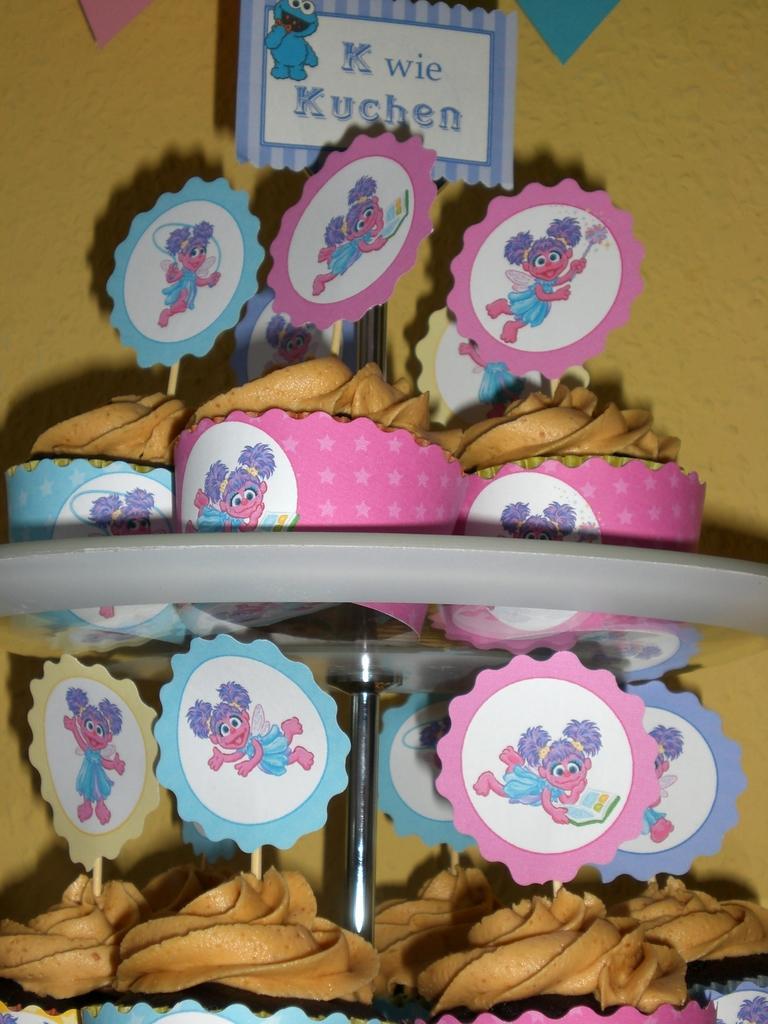What type of food is visible in the image? The facts provided do not specify the type of food in the image. What material are the rods made of in the image? The rods in the image are made of metal. What degree of difficulty is the meal in the image rated? There is no meal present in the image, so it is not possible to rate its difficulty. 